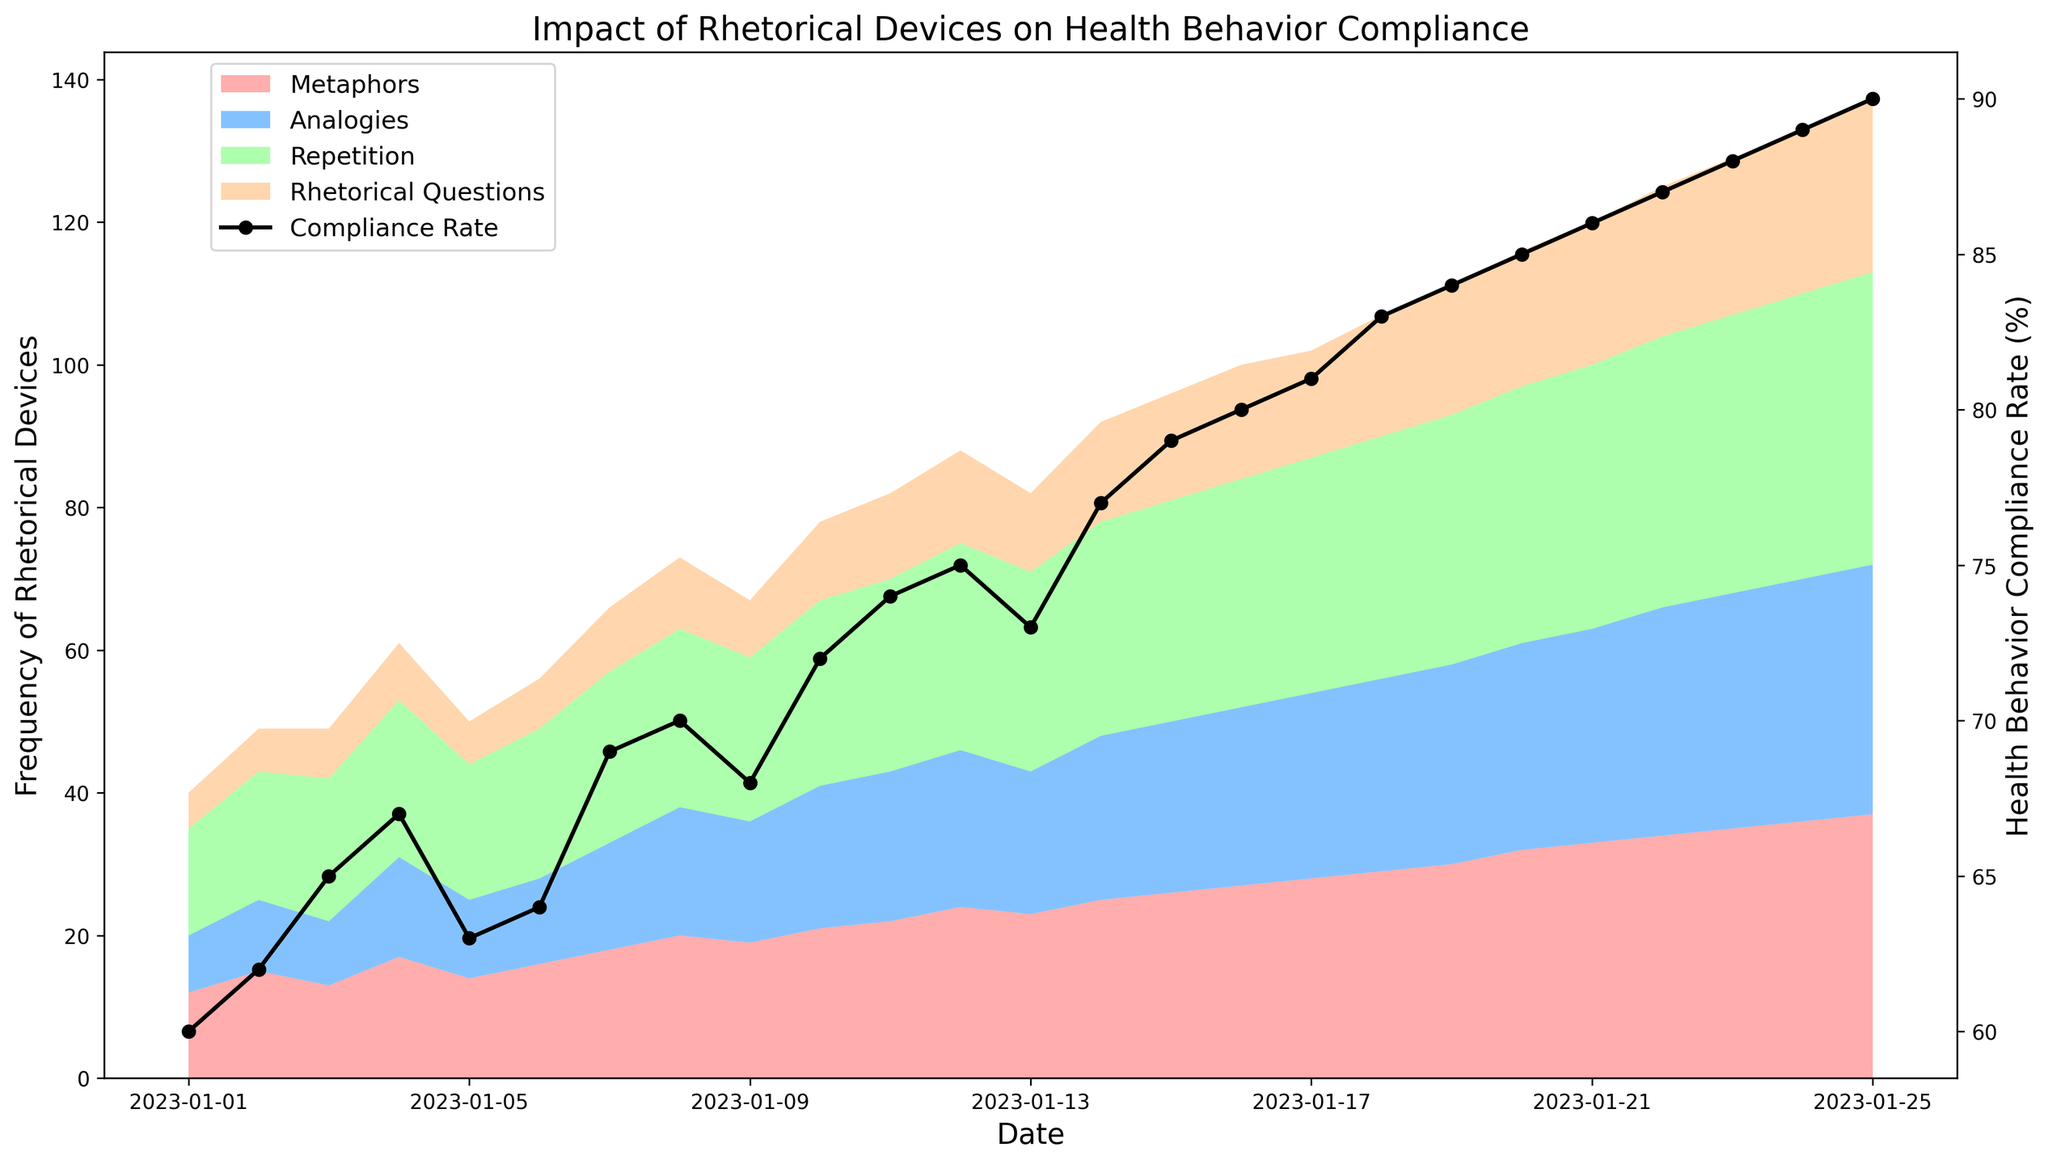What's the initial compliance rate at the start of the period? Look at the y-axis on the right side of the chart and find the value corresponding to January 1. The compliance rate on January 1 is marked as 60%.
Answer: 60% How did the frequency of Analogies and Metaphors compare on January 10th? On January 10th, find the heights of the Analogies and Metaphors areas. Analogies are lower but close to the top, indicating a frequency of 20. Metaphors are just below Analogies, with a frequency of 21.
Answer: Analogies: 20, Metaphors: 21 What is the total frequency of rhetorical devices used on January 15? Sum the values of Metaphors, Analogies, Repetition, and Rhetorical Questions on January 15. The values are 26, 24, 31, and 15 respectively. Therefore, the total is 26 + 24 + 31 + 15.
Answer: 96 On which date did the compliance rate first reach 80%? Look at the compliance rate plot and find the date where the rate first touches 80% on the y-axis. The plot shows that the compliance rate reached 80% on January 16.
Answer: January 16 Is the compliance rate always increasing? Observe the black line representing the compliance rate over time. The rate increases continuously with minor fluctuations but no major drop.
Answer: Yes Which rhetorical device shows the largest increase in frequency over the period? Compare the starting and ending heights (on January 1 and January 25) of the colored areas representing each rhetorical device. The area representing Metaphors has the largest increase, from 12 on January 1 to 37 on January 25.
Answer: Metaphors What's the difference in health behavior compliance rate between January 1 and January 25? Find the compliance rates for January 1 and January 25, which are 60% and 90% respectively. Subtract the initial rate from the final: 90% - 60%.
Answer: 30% How does the frequency of Rhetorical Questions on January 21 compare to the overall pattern for this device? Check the frequency of Rhetorical Questions on January 21, which is 20. Throughout the period, there's a steady increase, so the value on January 21 fits within this gradually increasing trend.
Answer: Consistent What is the sum of health behavior compliance rates from January 1 to January 10? Sum the compliance rates of each day from January 1 to January 10 (60 + 62 + 65 + 67 + 63 + 64 + 69 + 70 + 68 + 72).
Answer: 660 Is there a clear correlation between the frequency of rhetorical questions and the compliance rate? Observe the trends of both the areas representing Rhetorical Questions and the compliance rate line. Both have an upward trend with increasing values over time, indicating a positive correlation.
Answer: Yes 